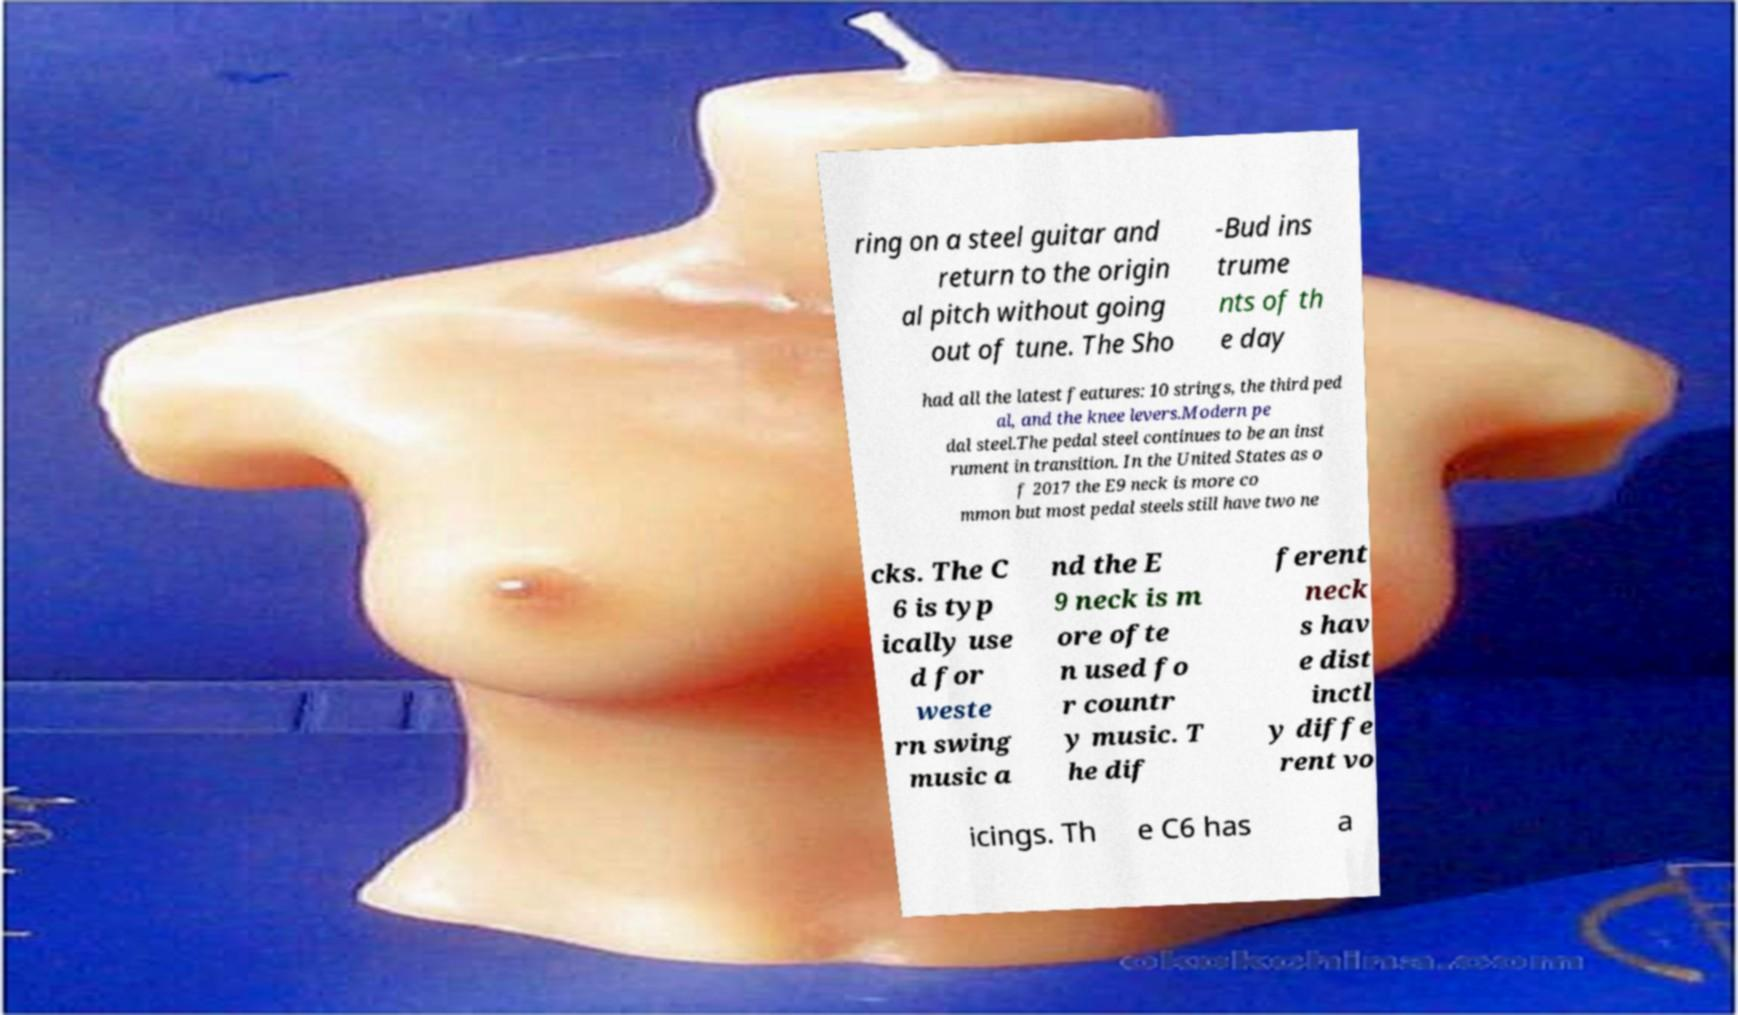What messages or text are displayed in this image? I need them in a readable, typed format. ring on a steel guitar and return to the origin al pitch without going out of tune. The Sho -Bud ins trume nts of th e day had all the latest features: 10 strings, the third ped al, and the knee levers.Modern pe dal steel.The pedal steel continues to be an inst rument in transition. In the United States as o f 2017 the E9 neck is more co mmon but most pedal steels still have two ne cks. The C 6 is typ ically use d for weste rn swing music a nd the E 9 neck is m ore ofte n used fo r countr y music. T he dif ferent neck s hav e dist inctl y diffe rent vo icings. Th e C6 has a 